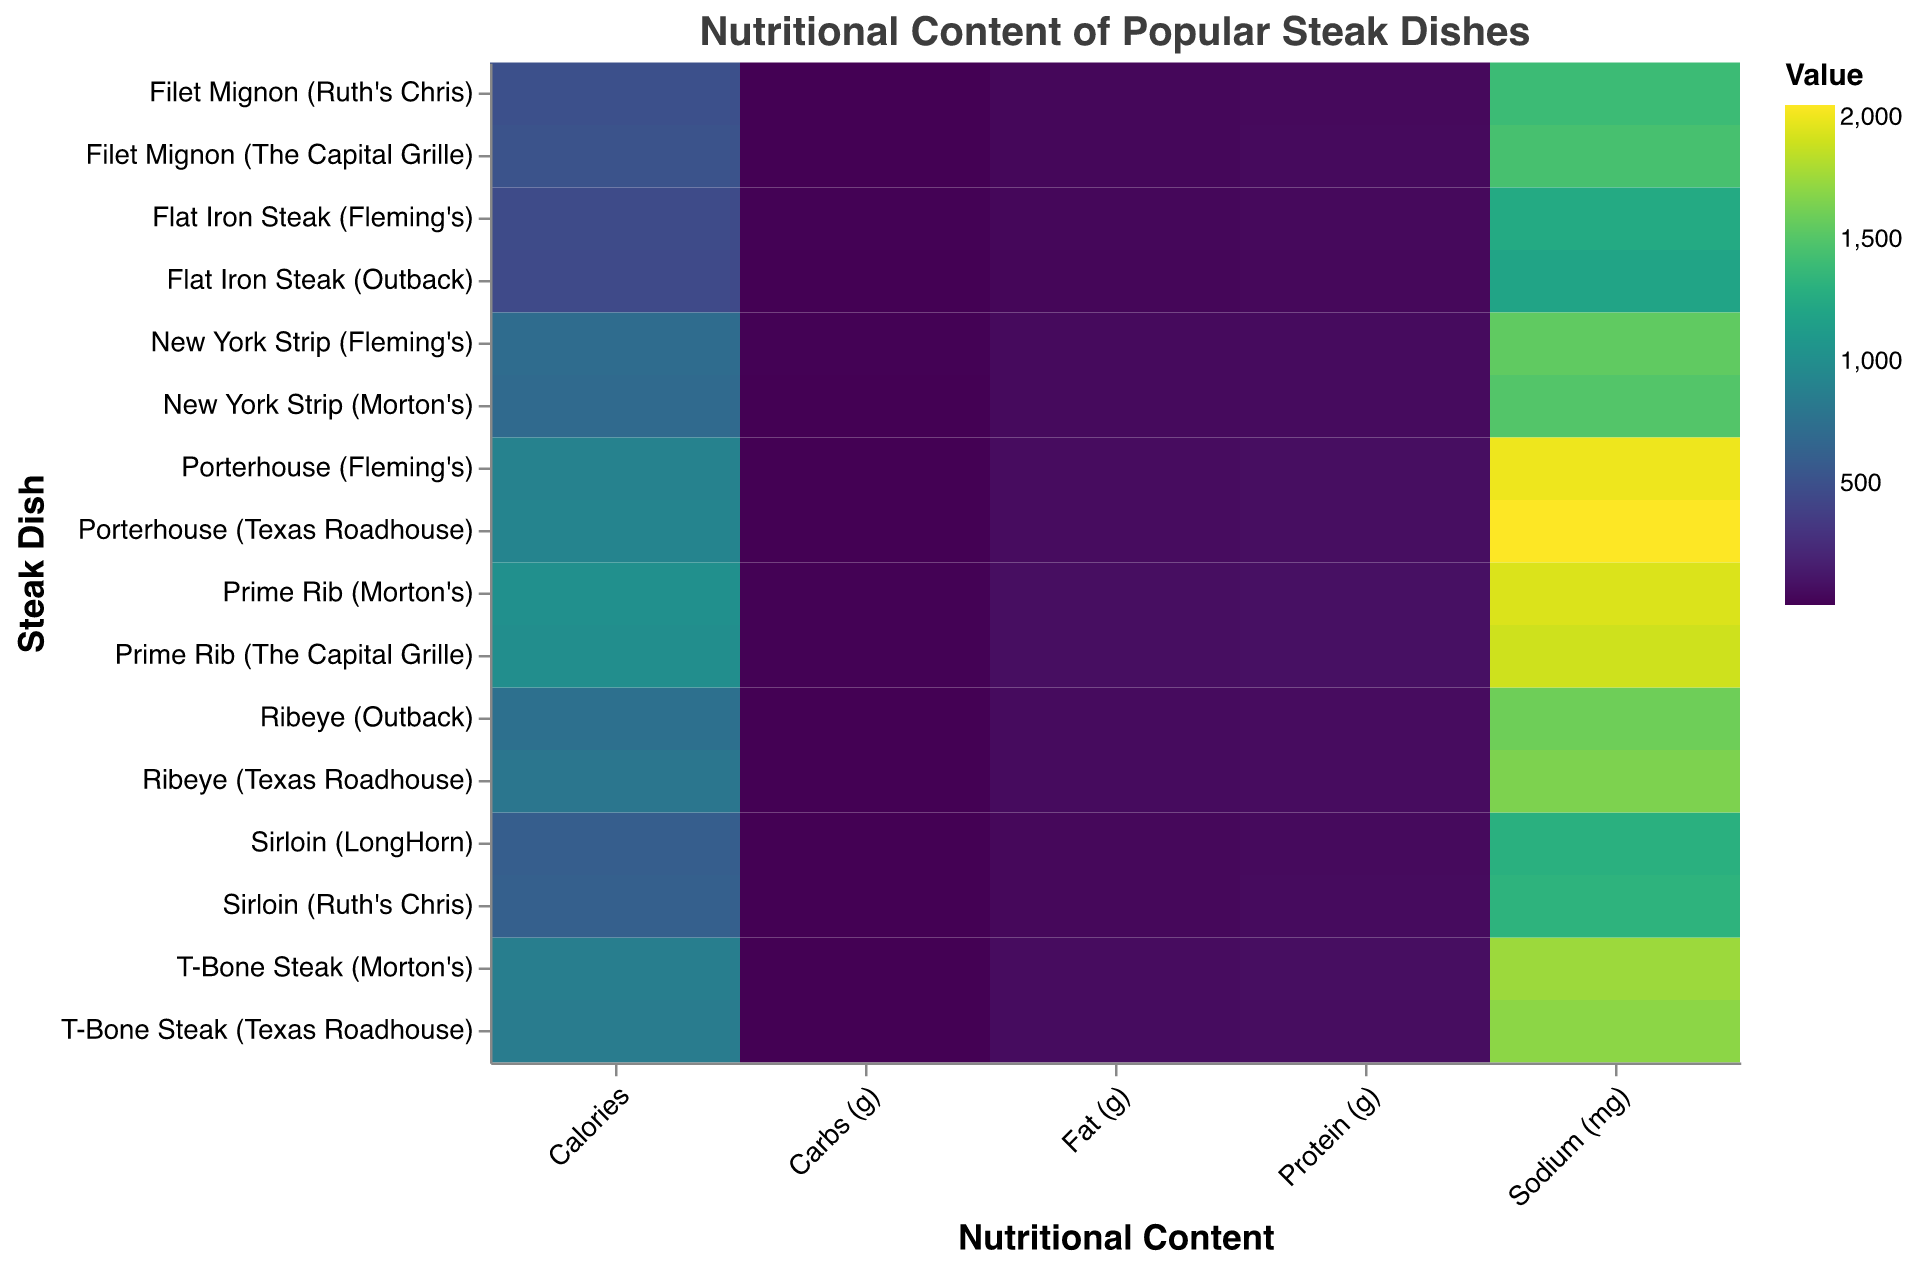What's the title of the figure? The title is visible at the top of the figure. It should summarize the content of the heatmap.
Answer: Nutritional Content of Popular Steak Dishes What is the color scheme used in the heatmap? The color scheme is typically specified in the visual properties of the heatmap. In this case, the color scale is mentioned to be 'viridis', a type of multi-hue color scheme.
Answer: viridis Which steak dish has the highest calorie count? Observe the color intensity for the 'Calories' column. The darkest color usually represents the highest value. The steak dish with the darkest color in the 'Calories' column will have the highest calorie count.
Answer: Prime Rib (Morton's) What is the protein content of the Ribeye from Outback? Look at the row labeled 'Ribeye (Outback)' and find the cell under the 'Protein (g)' column. The number in that cell represents the protein content.
Answer: 60g Which dish has the highest sodium content? Check the sodium column for the darkest shade, which represents the highest value. Identify the corresponding row for the dish.
Answer: Porterhouse (Texas Roadhouse) Find the average protein content of all steak dishes listed. Sum the protein values of all dishes and divide by the number of dishes: (60 + 45 + 65 + 55 + 70 + 50 + 80 + 40 + 62 + 47 + 68 + 57 + 72 + 52 + 82 + 42) / 16
Answer: 59.625g How does the fat content of Filet Mignon (Ruth's Chris) compare to that of Filet Mignon (The Capital Grille)? Compare the values under the 'Fat (g)' column for the respective rows labeled 'Filet Mignon (Ruth's Chris)' and 'Filet Mignon (The Capital Grille)'.
Answer: 35g vs 36g Which steak dish has both high protein (>70g) and high fat (>60g) content? Look for the cells with values greater than 70 in the 'Protein (g)' column and values greater than 60 in the 'Fat (g)' column. The intersection of these criteria gives the dish.
Answer: Prime Rib (Morton's) What is the median fat content among all steak dishes? List all fat values, sort them and find the middle value. If there's an even number of values, average the two middle ones: (55, 35, 58, 50, 60, 40, 70, 30, 57, 36, 59, 51, 61, 41, 72, 32). Sorted list: 30, 32, 35, 36, 40, 41, 50, 51, 55, 57, 58, 59, 60, 61, 70, 72. Median is average of 51 and 55.
Answer: 53g Which steakhouse has the broadest range of sodium content in their dishes? Look at the sodium values for dishes from each steakhouse and identify the range (max - min). Compare ranges for all steakhouses.
Answer: Texas Roadhouse (range: 2050 - 1600 = 450 mg) 